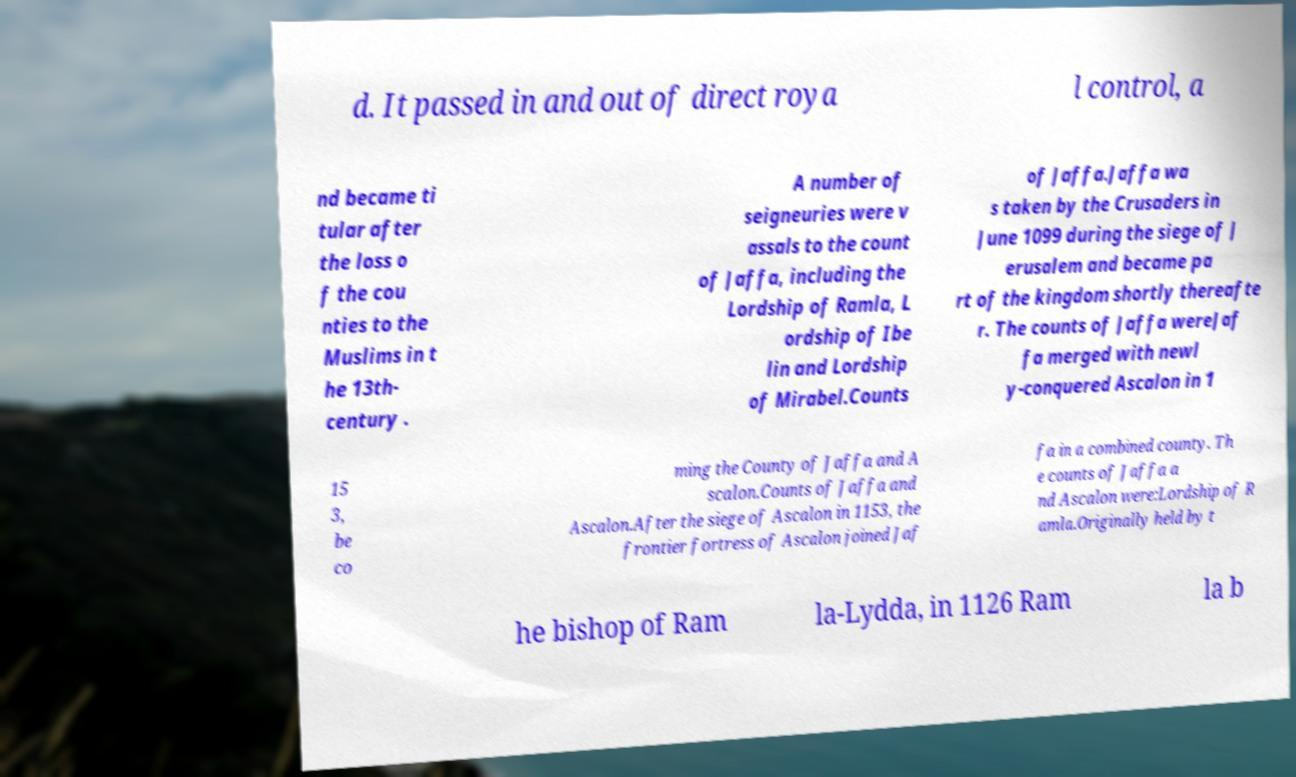What messages or text are displayed in this image? I need them in a readable, typed format. d. It passed in and out of direct roya l control, a nd became ti tular after the loss o f the cou nties to the Muslims in t he 13th- century . A number of seigneuries were v assals to the count of Jaffa, including the Lordship of Ramla, L ordship of Ibe lin and Lordship of Mirabel.Counts of Jaffa.Jaffa wa s taken by the Crusaders in June 1099 during the siege of J erusalem and became pa rt of the kingdom shortly thereafte r. The counts of Jaffa wereJaf fa merged with newl y-conquered Ascalon in 1 15 3, be co ming the County of Jaffa and A scalon.Counts of Jaffa and Ascalon.After the siege of Ascalon in 1153, the frontier fortress of Ascalon joined Jaf fa in a combined county. Th e counts of Jaffa a nd Ascalon were:Lordship of R amla.Originally held by t he bishop of Ram la-Lydda, in 1126 Ram la b 